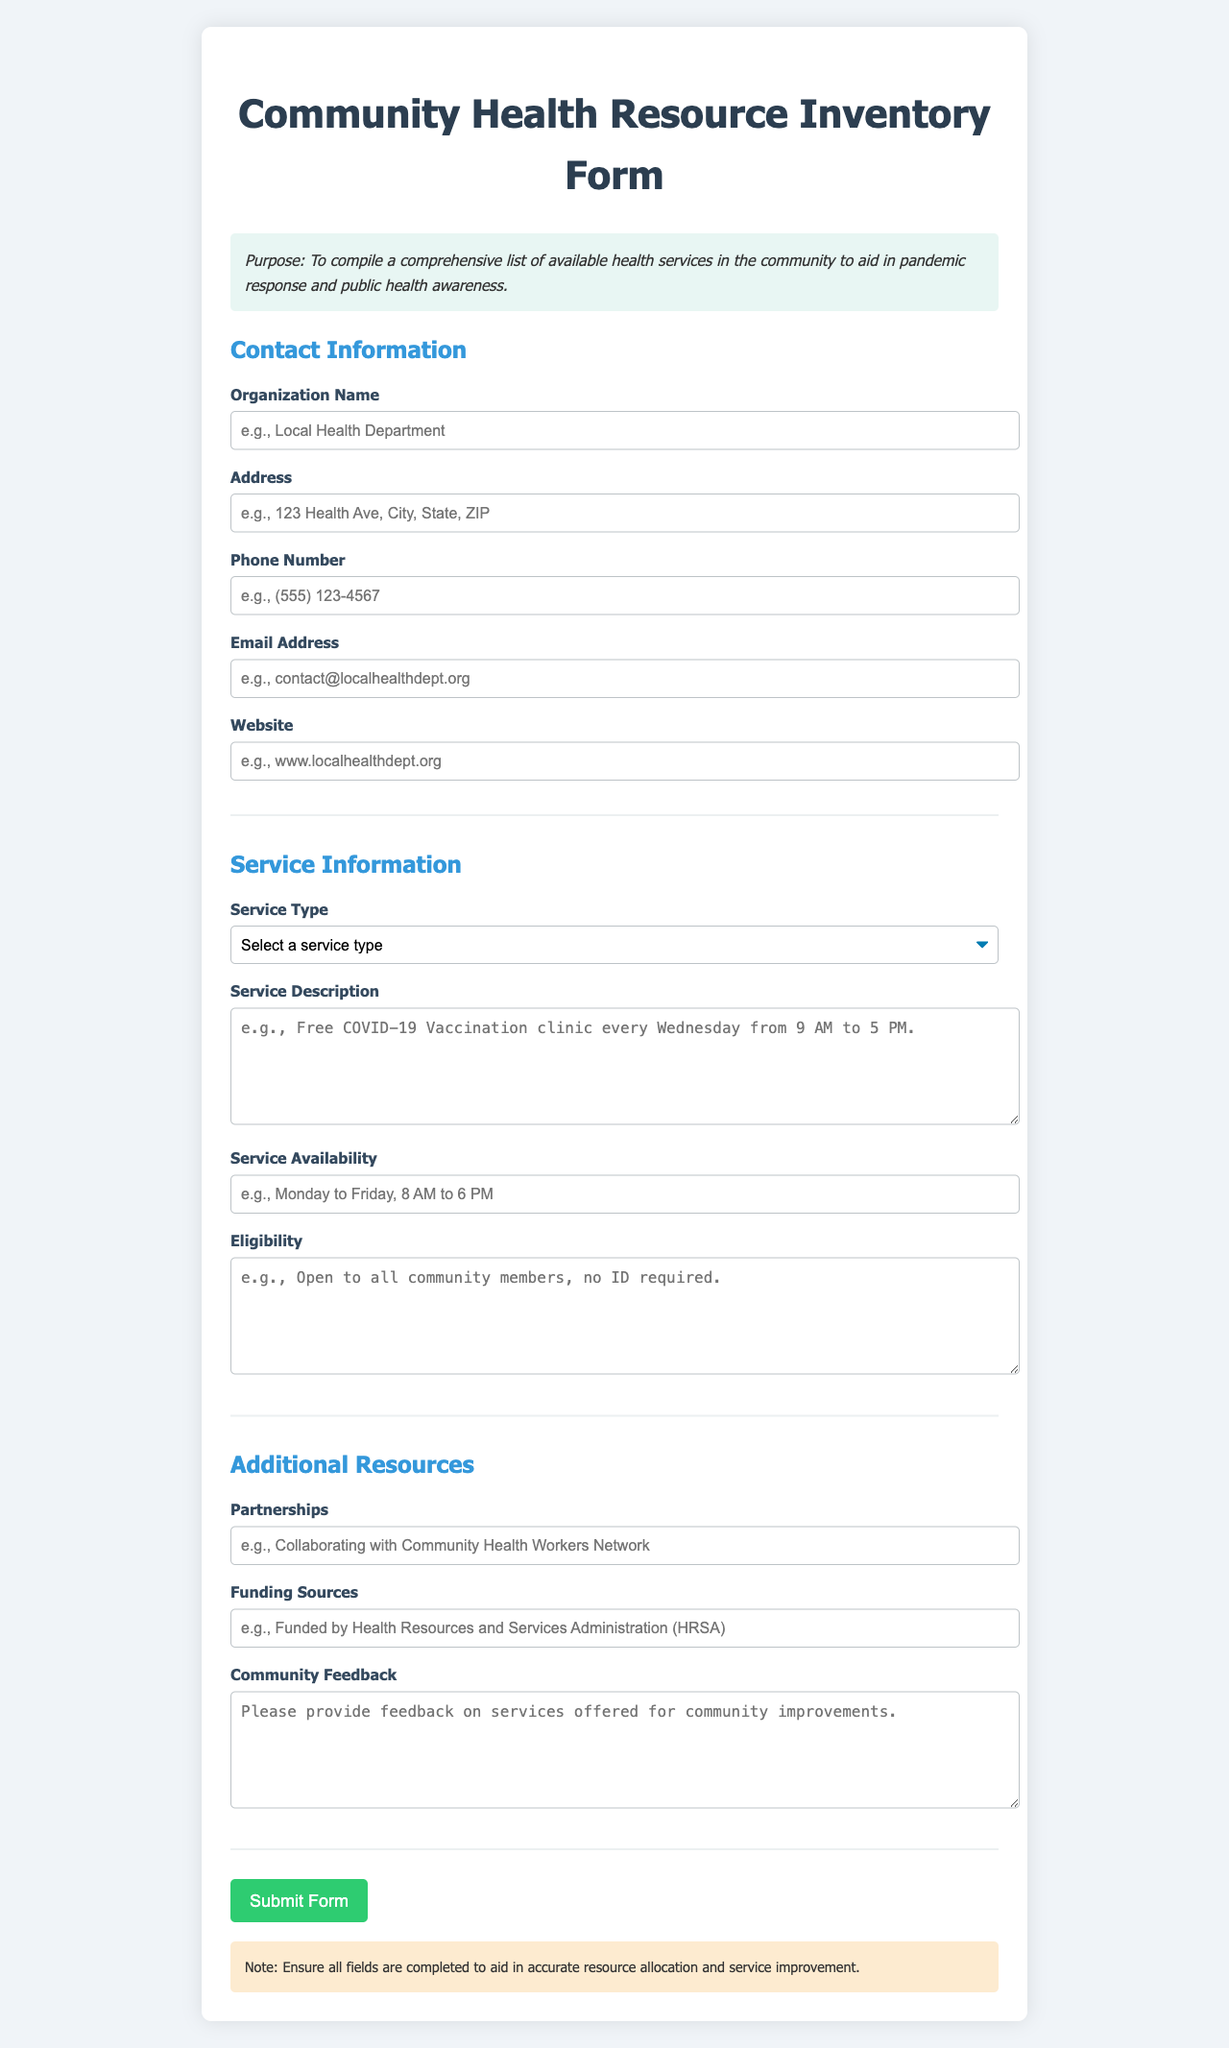What is the purpose of the form? The purpose of the form is stated at the beginning as compiling a comprehensive list of available health services in the community to aid in pandemic response and public health awareness.
Answer: To compile a comprehensive list of available health services in the community What type of service can be selected? The document lists several service types in a dropdown menu for selection, including vaccination and testing.
Answer: Vaccination What is the section title for contact details? The section that contains contact details is specifically titled in the document.
Answer: Contact Information What is required in the eligibility section? The eligibility section is meant for describing the required criteria for accessing the service, as indicated by the label.
Answer: Open to all community members, no ID required What organization might collaborate according to the form? The partnerships field allows input on collaboration efforts, which provides insight into potential partners for services.
Answer: Community Health Workers Network What is the color of the submit button? The submit button is designed with a specific color, which can be easily identified in the form styling.
Answer: Green What should be ensured before submitting the form? The document contains a note instructing what needs to be completed before submission.
Answer: Ensure all fields are completed What does the service availability specify? The service availability input is intended to provide information on when services can be accessed.
Answer: Monday to Friday, 8 AM to 6 PM What is noted about community feedback? The community feedback section invites input on services, showing an aspect of engagement with the community.
Answer: Please provide feedback on services offered for community improvements 